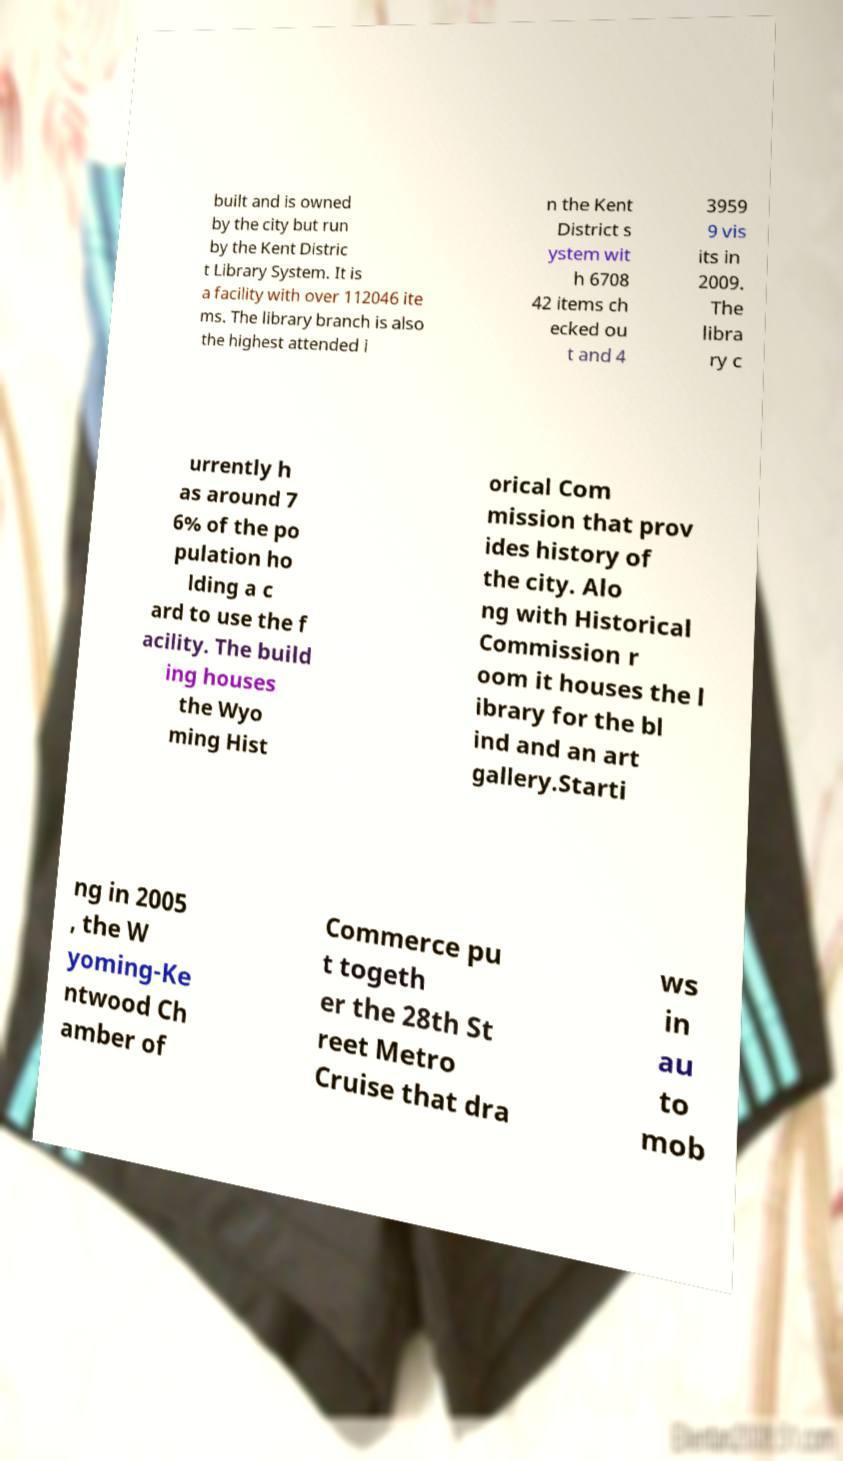Could you assist in decoding the text presented in this image and type it out clearly? built and is owned by the city but run by the Kent Distric t Library System. It is a facility with over 112046 ite ms. The library branch is also the highest attended i n the Kent District s ystem wit h 6708 42 items ch ecked ou t and 4 3959 9 vis its in 2009. The libra ry c urrently h as around 7 6% of the po pulation ho lding a c ard to use the f acility. The build ing houses the Wyo ming Hist orical Com mission that prov ides history of the city. Alo ng with Historical Commission r oom it houses the l ibrary for the bl ind and an art gallery.Starti ng in 2005 , the W yoming-Ke ntwood Ch amber of Commerce pu t togeth er the 28th St reet Metro Cruise that dra ws in au to mob 